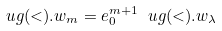Convert formula to latex. <formula><loc_0><loc_0><loc_500><loc_500>\ u g ( < ) . w _ { m } = e _ { 0 } ^ { m + 1 } \ u g ( < ) . w _ { \lambda }</formula> 